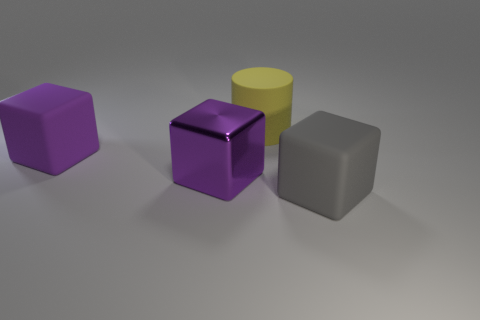Add 1 gray rubber blocks. How many objects exist? 5 Subtract all cubes. How many objects are left? 1 Add 3 purple matte blocks. How many purple matte blocks exist? 4 Subtract 0 green cylinders. How many objects are left? 4 Subtract all brown metal things. Subtract all purple rubber blocks. How many objects are left? 3 Add 4 large gray blocks. How many large gray blocks are left? 5 